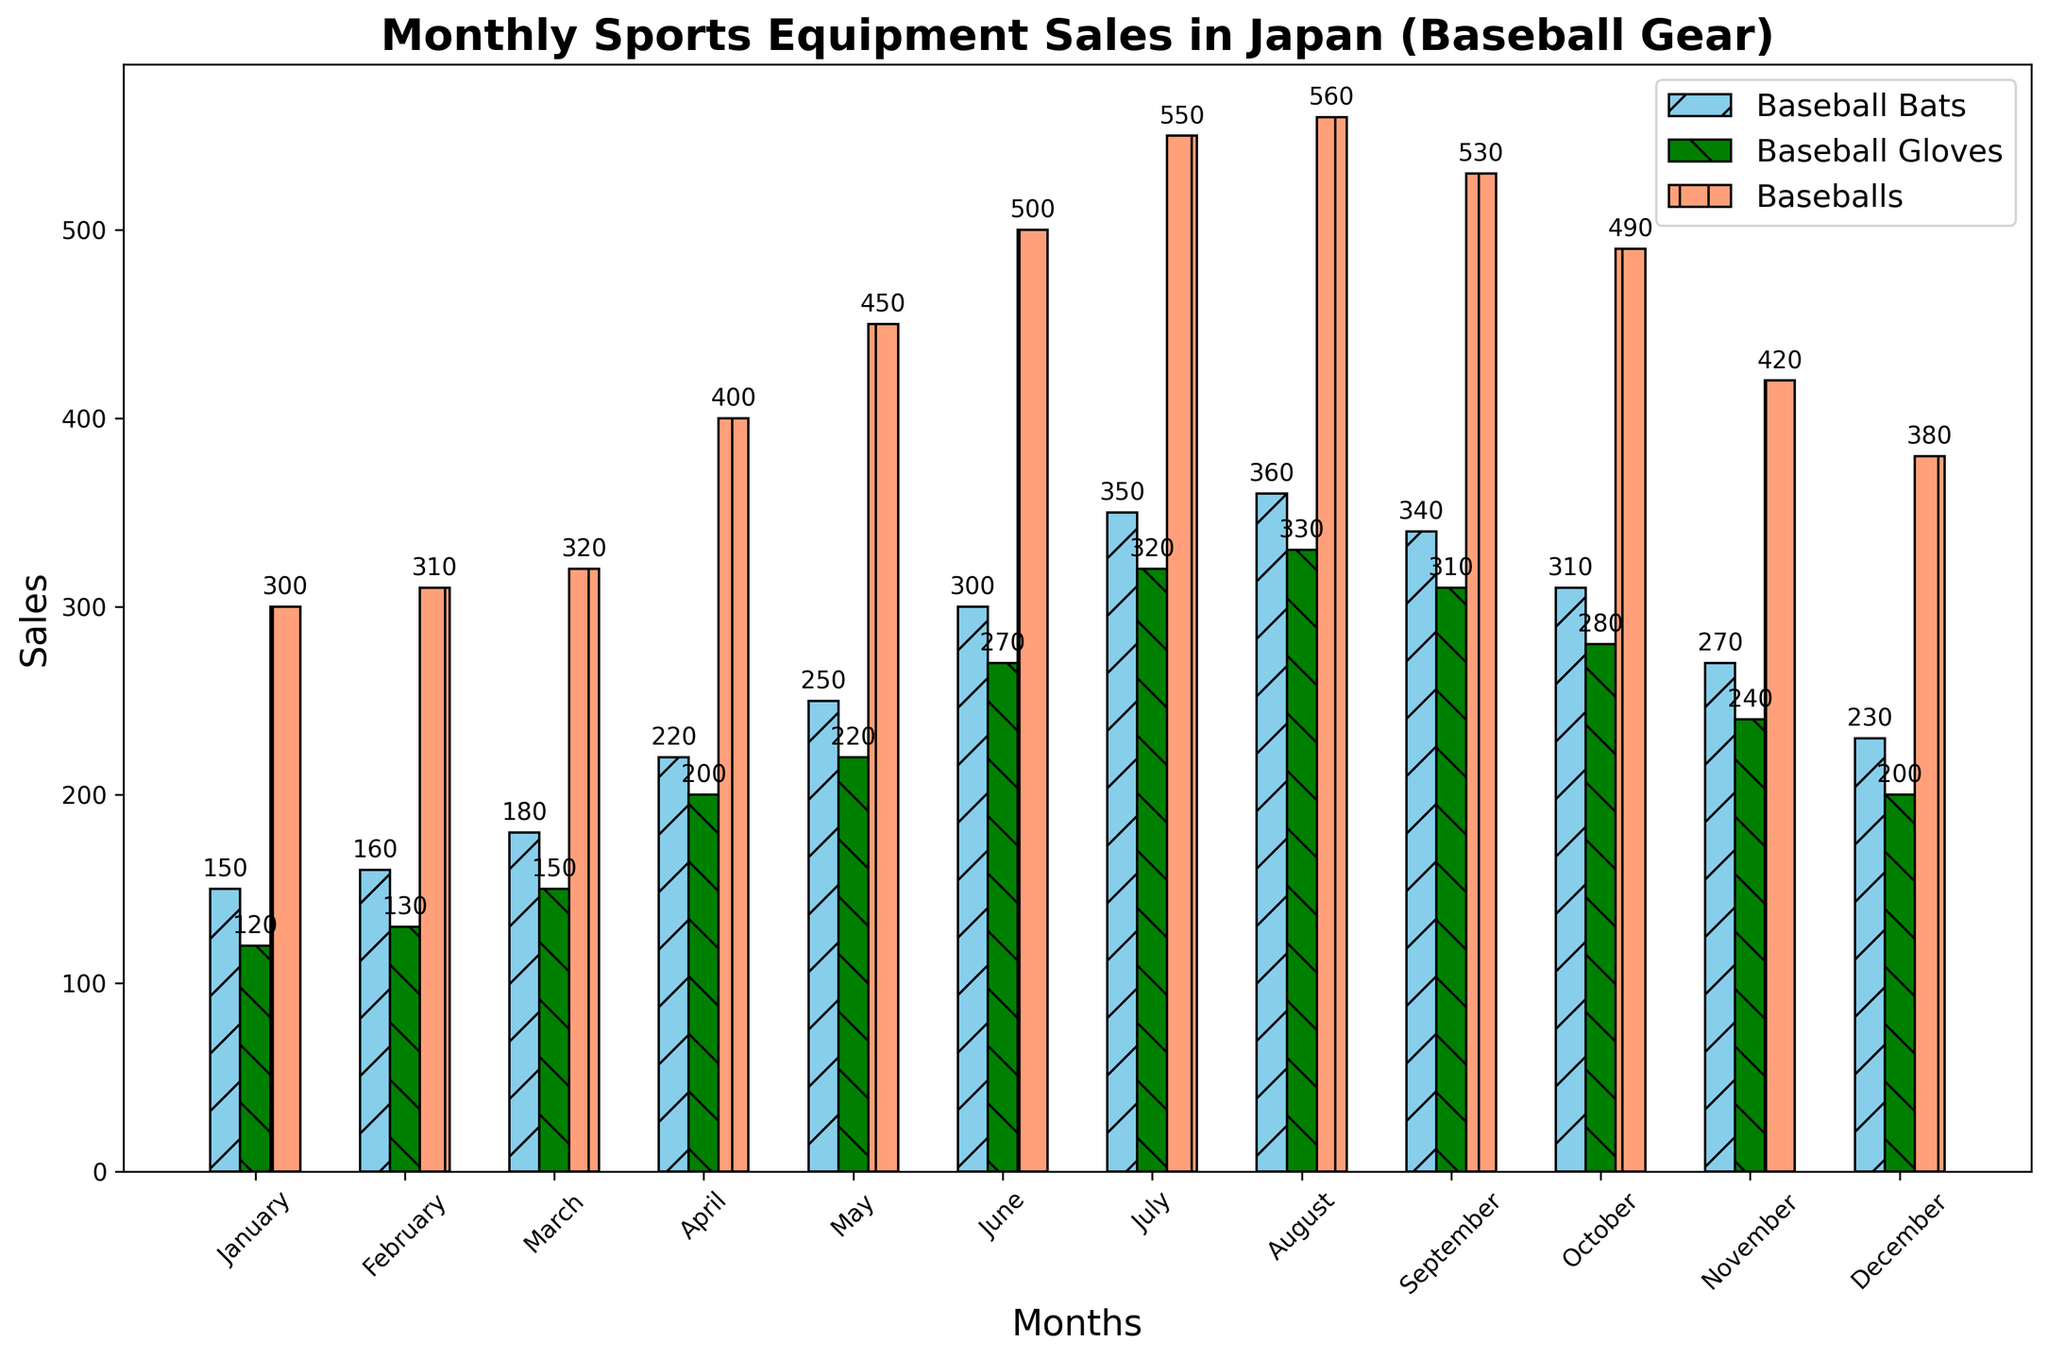Which month saw the highest sales for baseball bats? The bar for Baseball Bats is the tallest in August when comparing all months.
Answer: August Which month had the lowest sales for baseball gloves? The bar for Baseball Gloves is the shortest in January when visualizing all months.
Answer: January What are the total sales for baseballs in March and April? The height of the March bar for Baseballs is 320 and for April is 400. Summing these values gives 320 + 400 = 720.
Answer: 720 Did the sales of baseball bats in July exceed those in September? The bar for Baseball Bats in July is taller than the one in September. The value for July is 350 and for September is 340, so 350 > 340.
Answer: Yes What's the difference in baseball glove sales between May and October? From the figure, sales in May are 220 and in October are 280. The difference is 280 - 220 = 60.
Answer: 60 In which month did baseball gloves and baseballs have the same sales volume? Visualizing the bars, we see that baseball gloves and baseballs do not have any overlapping heights in any month.
Answer: None Which product had the most consistent sales throughout the year? Visual scanning reveals that baseball bats have smaller fluctuations in bar heights compared to baseball gloves and baseballs.
Answer: Baseball bats What is the average sale of baseballs over the entire year? Summing the Baseballs sales from January to December: 300 + 310 + 320 + 400 + 450 + 500 + 550 + 560 + 530 + 490 + 420 + 380 = 5210. There are 12 months, so the average is 5210 / 12 ≈ 434.
Answer: 434 Comparing June, which item had the lowest sales? In June, the bars for Baseball Bats, Baseball Gloves, and Baseballs are at 300, 270, and 500 respectively. The lowest is for Baseball Gloves at 270.
Answer: Baseball gloves Which month had a noticeable drop in baseball sales after continuous growth? Observing continuous growth and then a drop, from August to September the Baseballs sales decrease from 560 to 530.
Answer: September 